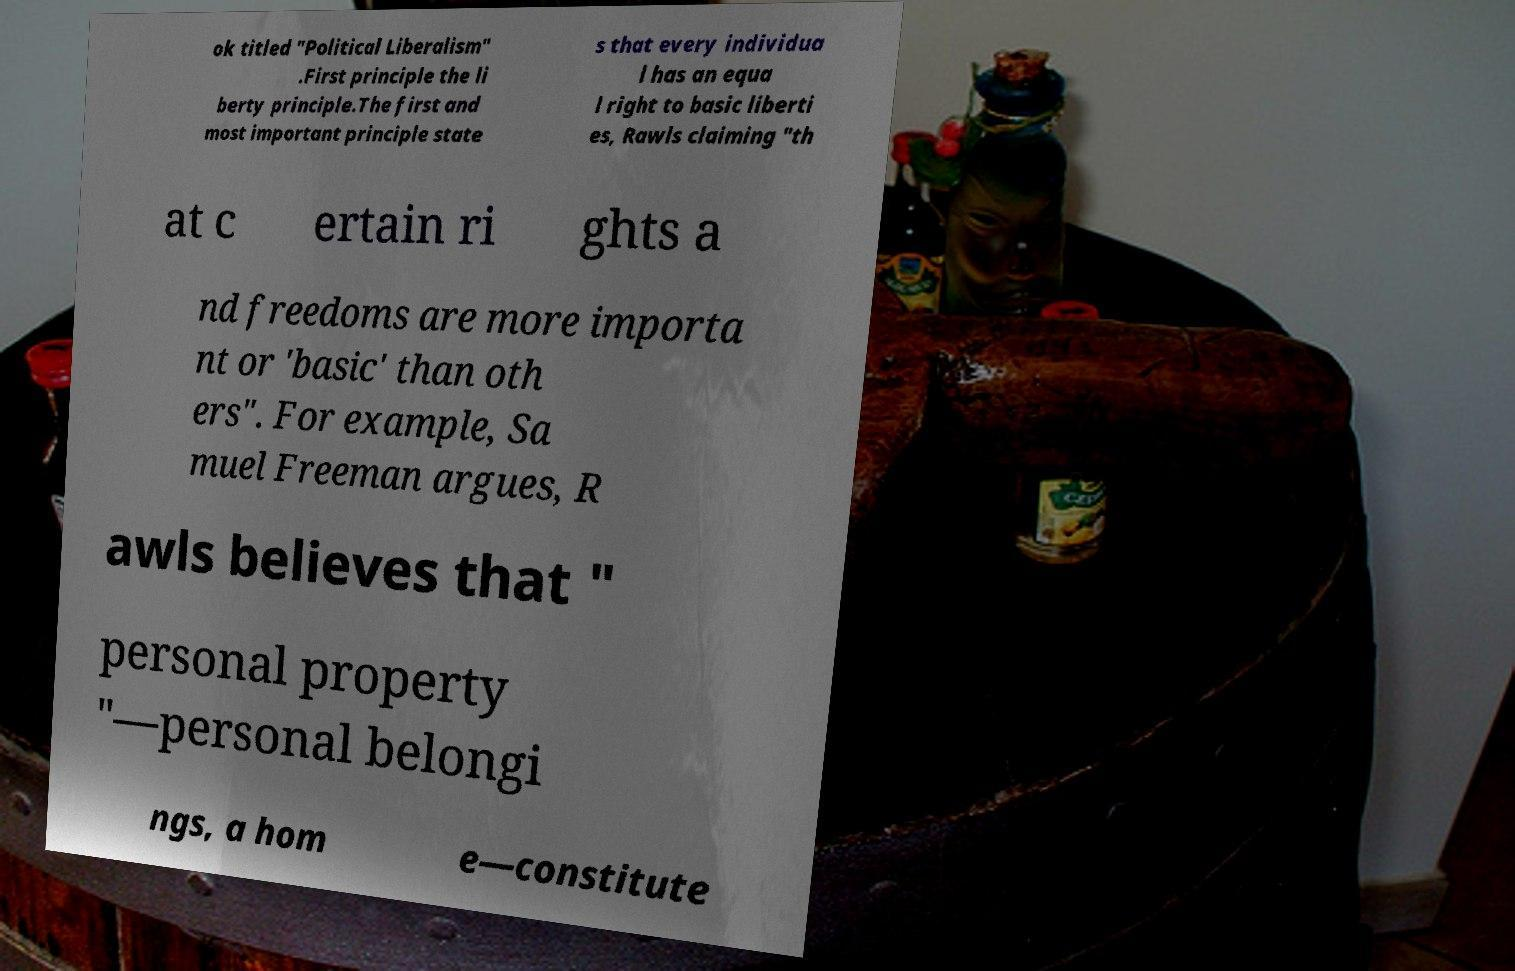Can you read and provide the text displayed in the image?This photo seems to have some interesting text. Can you extract and type it out for me? ok titled "Political Liberalism" .First principle the li berty principle.The first and most important principle state s that every individua l has an equa l right to basic liberti es, Rawls claiming "th at c ertain ri ghts a nd freedoms are more importa nt or 'basic' than oth ers". For example, Sa muel Freeman argues, R awls believes that " personal property "—personal belongi ngs, a hom e—constitute 